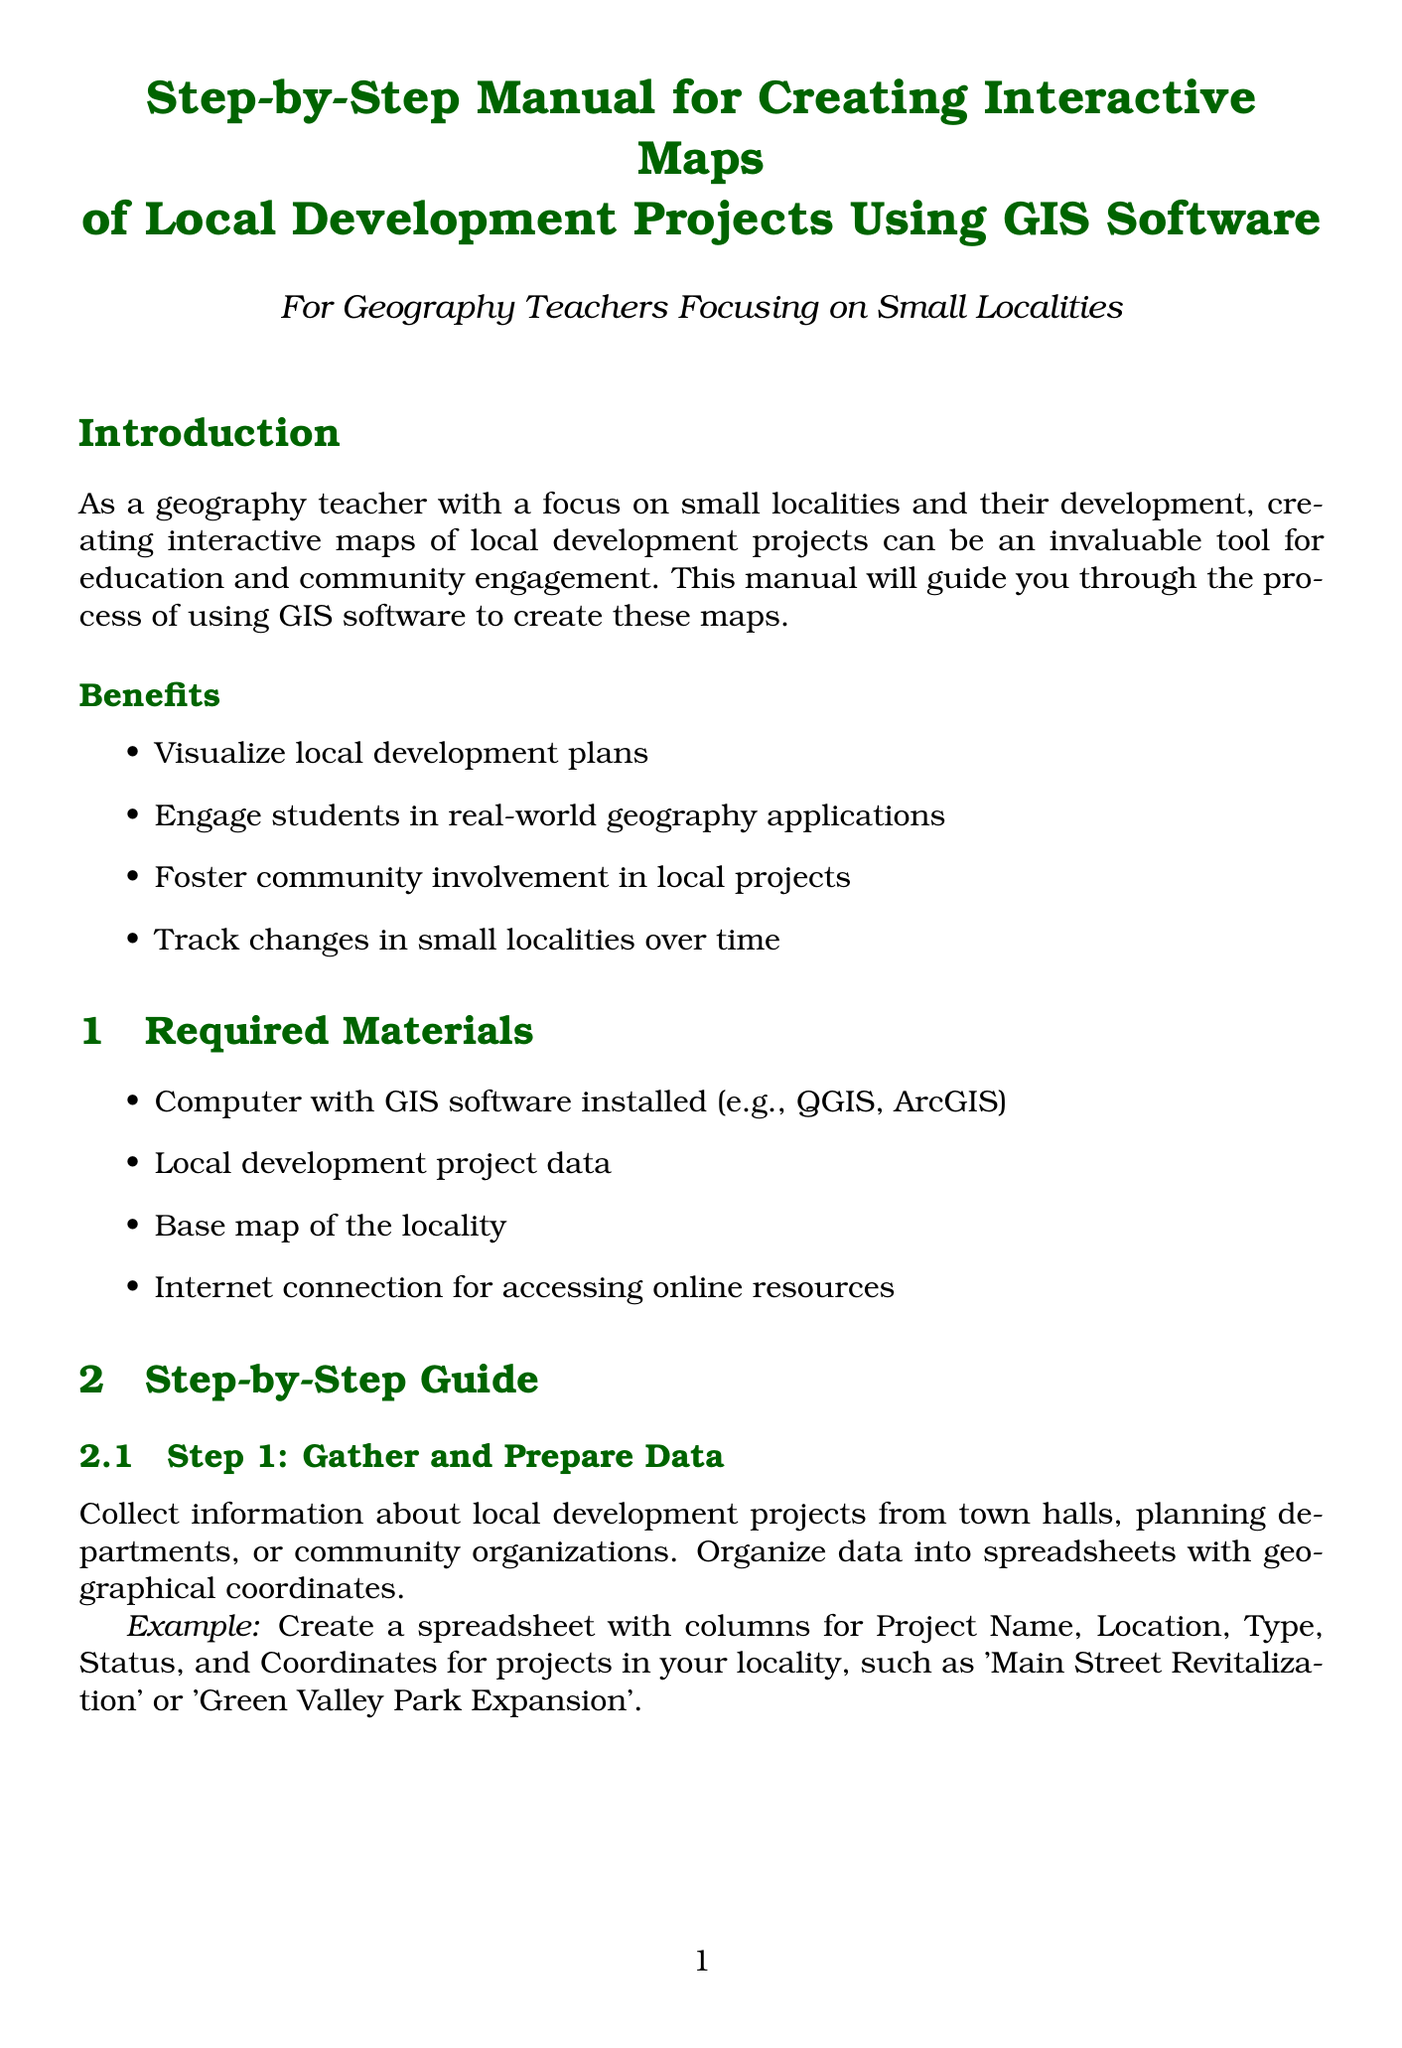What is the title of the manual? The title clearly indicates the purpose of the document, which is to guide the creation of interactive maps using GIS software.
Answer: Step-by-Step Manual for Creating Interactive Maps of Local Development Projects Using GIS Software How many steps are in the guide? Counting the steps listed will provide the number of steps for creating interactive maps.
Answer: Ten What is one example of required material? The document lists materials needed to create interactive maps, and one can be identified from this list.
Answer: Computer with GIS software installed What does Step 5 focus on? The description of Step 5 provides insight into what specific task is emphasized during the mapping process.
Answer: Symbolize Project Points Which software is suggested for use? The introduction mentions GIS software that is suitable for creating maps.
Answer: QGIS What is the purpose of pop-ups in the map? The document highlights the role of pop-ups in displaying additional information when interacting with the map.
Answer: Display relevant details when clicked Which benefit focuses on community engagement? Among the benefits, one specifically addresses community involvement.
Answer: Foster community involvement in local projects What interactive feature is suggested in Step 8? The document elaborates on enhancing user experience through interactive tools.
Answer: Add a time slider Who should you collaborate with according to the next steps? The conclusion provides a recommendation for working with specific community members for data accuracy.
Answer: Local officials 